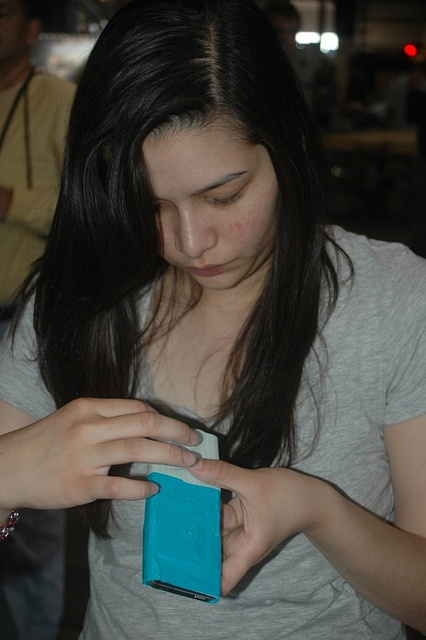Describe the objects in this image and their specific colors. I can see people in black and gray tones, people in black, olive, and gray tones, cell phone in black, teal, and darkgray tones, and cell phone in black, teal, purple, and darkblue tones in this image. 